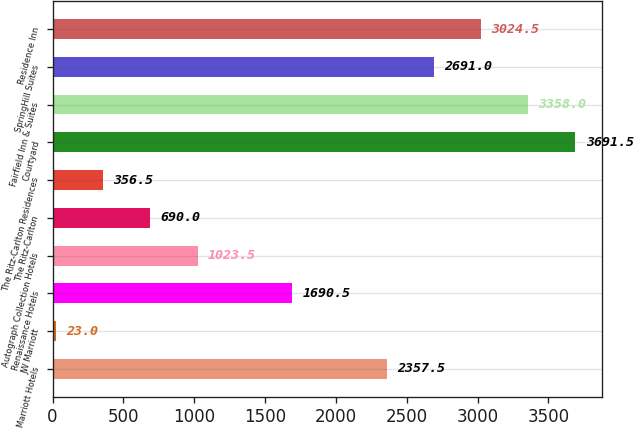<chart> <loc_0><loc_0><loc_500><loc_500><bar_chart><fcel>Marriott Hotels<fcel>JW Marriott<fcel>Renaissance Hotels<fcel>Autograph Collection Hotels<fcel>The Ritz-Carlton<fcel>The Ritz-Carlton Residences<fcel>Courtyard<fcel>Fairfield Inn & Suites<fcel>SpringHill Suites<fcel>Residence Inn<nl><fcel>2357.5<fcel>23<fcel>1690.5<fcel>1023.5<fcel>690<fcel>356.5<fcel>3691.5<fcel>3358<fcel>2691<fcel>3024.5<nl></chart> 